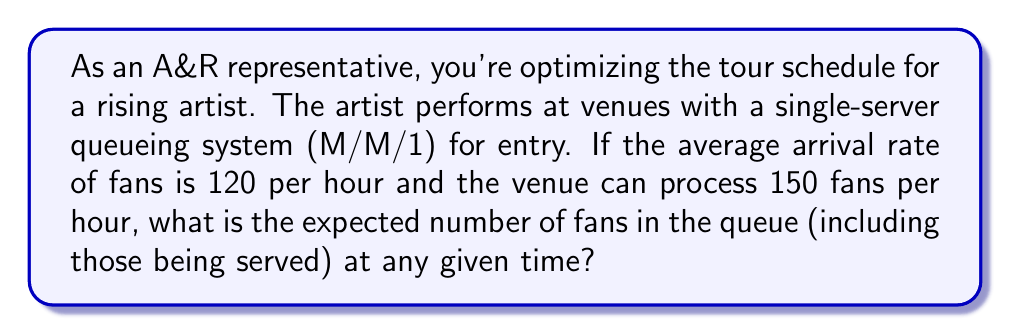Can you answer this question? To solve this problem, we'll use the M/M/1 queueing model and apply Little's Law. Let's break it down step-by-step:

1. Identify the given parameters:
   $\lambda$ = arrival rate = 120 fans/hour
   $\mu$ = service rate = 150 fans/hour

2. Calculate the utilization factor $\rho$:
   $$\rho = \frac{\lambda}{\mu} = \frac{120}{150} = 0.8$$

3. For an M/M/1 queue, the expected number of customers in the system (L) is given by:
   $$L = \frac{\rho}{1-\rho}$$

4. Substitute the calculated $\rho$ into the formula:
   $$L = \frac{0.8}{1-0.8} = \frac{0.8}{0.2} = 4$$

Therefore, the expected number of fans in the queue (including those being served) at any given time is 4.

This information is crucial for an A&R representative to optimize tour scheduling, as it helps in estimating venue capacity requirements and potential wait times for fans.
Answer: 4 fans 